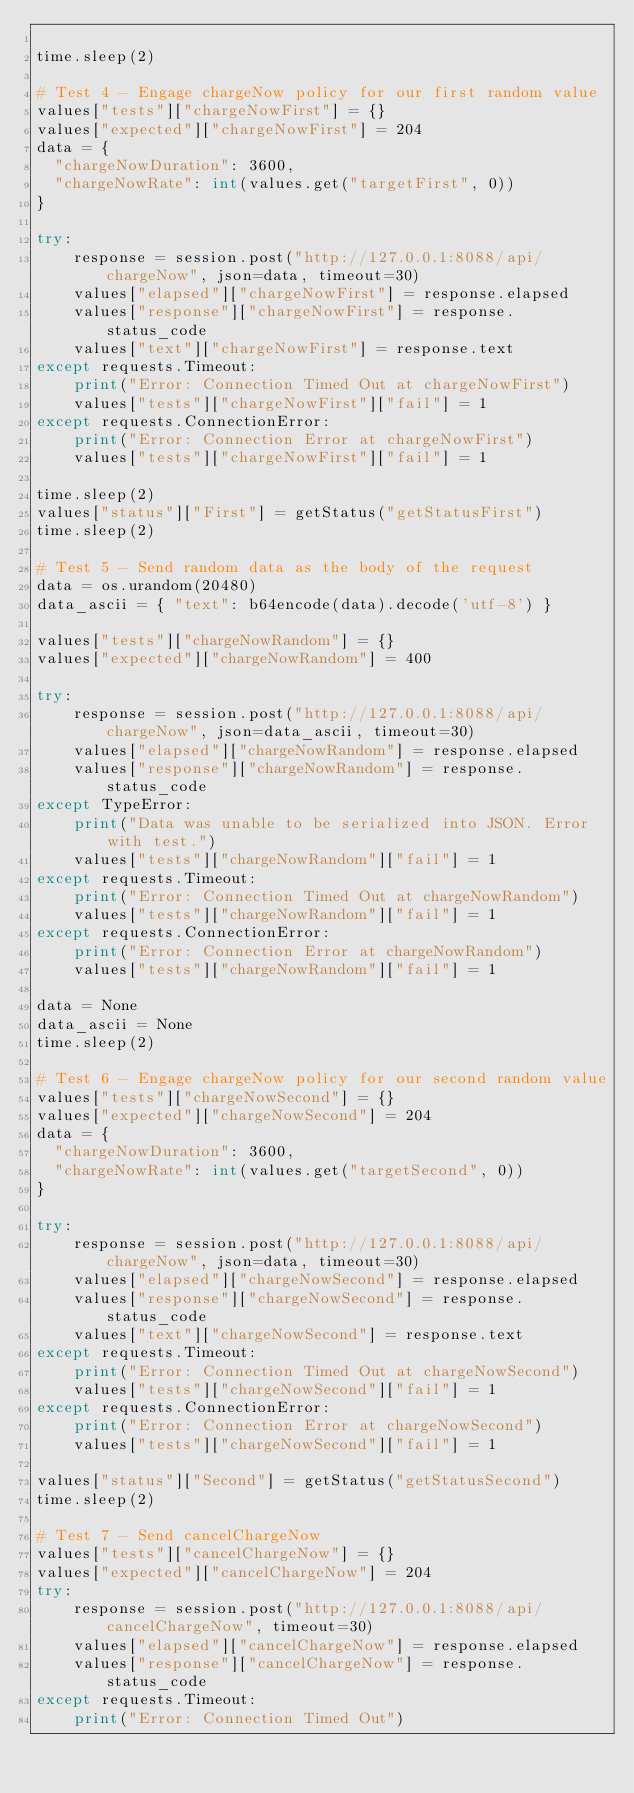<code> <loc_0><loc_0><loc_500><loc_500><_Python_>
time.sleep(2)

# Test 4 - Engage chargeNow policy for our first random value
values["tests"]["chargeNowFirst"] = {}
values["expected"]["chargeNowFirst"] = 204
data = {
  "chargeNowDuration": 3600,
  "chargeNowRate": int(values.get("targetFirst", 0))
}

try:
    response = session.post("http://127.0.0.1:8088/api/chargeNow", json=data, timeout=30)
    values["elapsed"]["chargeNowFirst"] = response.elapsed
    values["response"]["chargeNowFirst"] = response.status_code
    values["text"]["chargeNowFirst"] = response.text
except requests.Timeout:
    print("Error: Connection Timed Out at chargeNowFirst")
    values["tests"]["chargeNowFirst"]["fail"] = 1
except requests.ConnectionError:
    print("Error: Connection Error at chargeNowFirst")
    values["tests"]["chargeNowFirst"]["fail"] = 1

time.sleep(2)
values["status"]["First"] = getStatus("getStatusFirst")
time.sleep(2)

# Test 5 - Send random data as the body of the request
data = os.urandom(20480)
data_ascii = { "text": b64encode(data).decode('utf-8') }

values["tests"]["chargeNowRandom"] = {}
values["expected"]["chargeNowRandom"] = 400

try:
    response = session.post("http://127.0.0.1:8088/api/chargeNow", json=data_ascii, timeout=30)
    values["elapsed"]["chargeNowRandom"] = response.elapsed
    values["response"]["chargeNowRandom"] = response.status_code
except TypeError:
    print("Data was unable to be serialized into JSON. Error with test.")
    values["tests"]["chargeNowRandom"]["fail"] = 1
except requests.Timeout:
    print("Error: Connection Timed Out at chargeNowRandom")
    values["tests"]["chargeNowRandom"]["fail"] = 1
except requests.ConnectionError:
    print("Error: Connection Error at chargeNowRandom")
    values["tests"]["chargeNowRandom"]["fail"] = 1

data = None
data_ascii = None
time.sleep(2)

# Test 6 - Engage chargeNow policy for our second random value
values["tests"]["chargeNowSecond"] = {}
values["expected"]["chargeNowSecond"] = 204
data = {
  "chargeNowDuration": 3600,
  "chargeNowRate": int(values.get("targetSecond", 0))
}

try:
    response = session.post("http://127.0.0.1:8088/api/chargeNow", json=data, timeout=30)
    values["elapsed"]["chargeNowSecond"] = response.elapsed
    values["response"]["chargeNowSecond"] = response.status_code
    values["text"]["chargeNowSecond"] = response.text
except requests.Timeout:
    print("Error: Connection Timed Out at chargeNowSecond")
    values["tests"]["chargeNowSecond"]["fail"] = 1
except requests.ConnectionError:
    print("Error: Connection Error at chargeNowSecond")
    values["tests"]["chargeNowSecond"]["fail"] = 1

values["status"]["Second"] = getStatus("getStatusSecond")
time.sleep(2)

# Test 7 - Send cancelChargeNow
values["tests"]["cancelChargeNow"] = {}
values["expected"]["cancelChargeNow"] = 204
try:
    response = session.post("http://127.0.0.1:8088/api/cancelChargeNow", timeout=30)
    values["elapsed"]["cancelChargeNow"] = response.elapsed
    values["response"]["cancelChargeNow"] = response.status_code
except requests.Timeout:
    print("Error: Connection Timed Out")</code> 